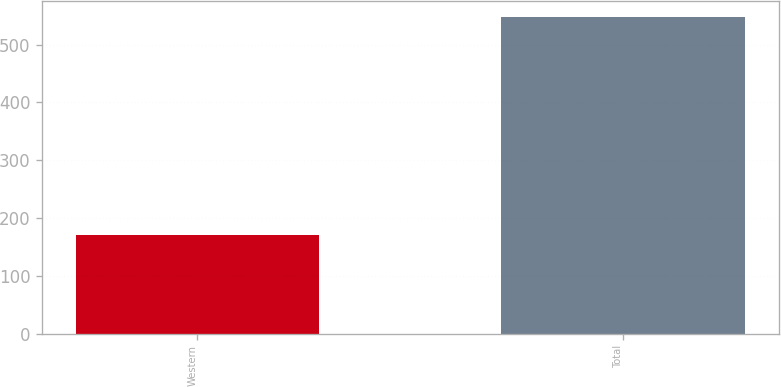Convert chart. <chart><loc_0><loc_0><loc_500><loc_500><bar_chart><fcel>Western<fcel>Total<nl><fcel>170.9<fcel>547.9<nl></chart> 